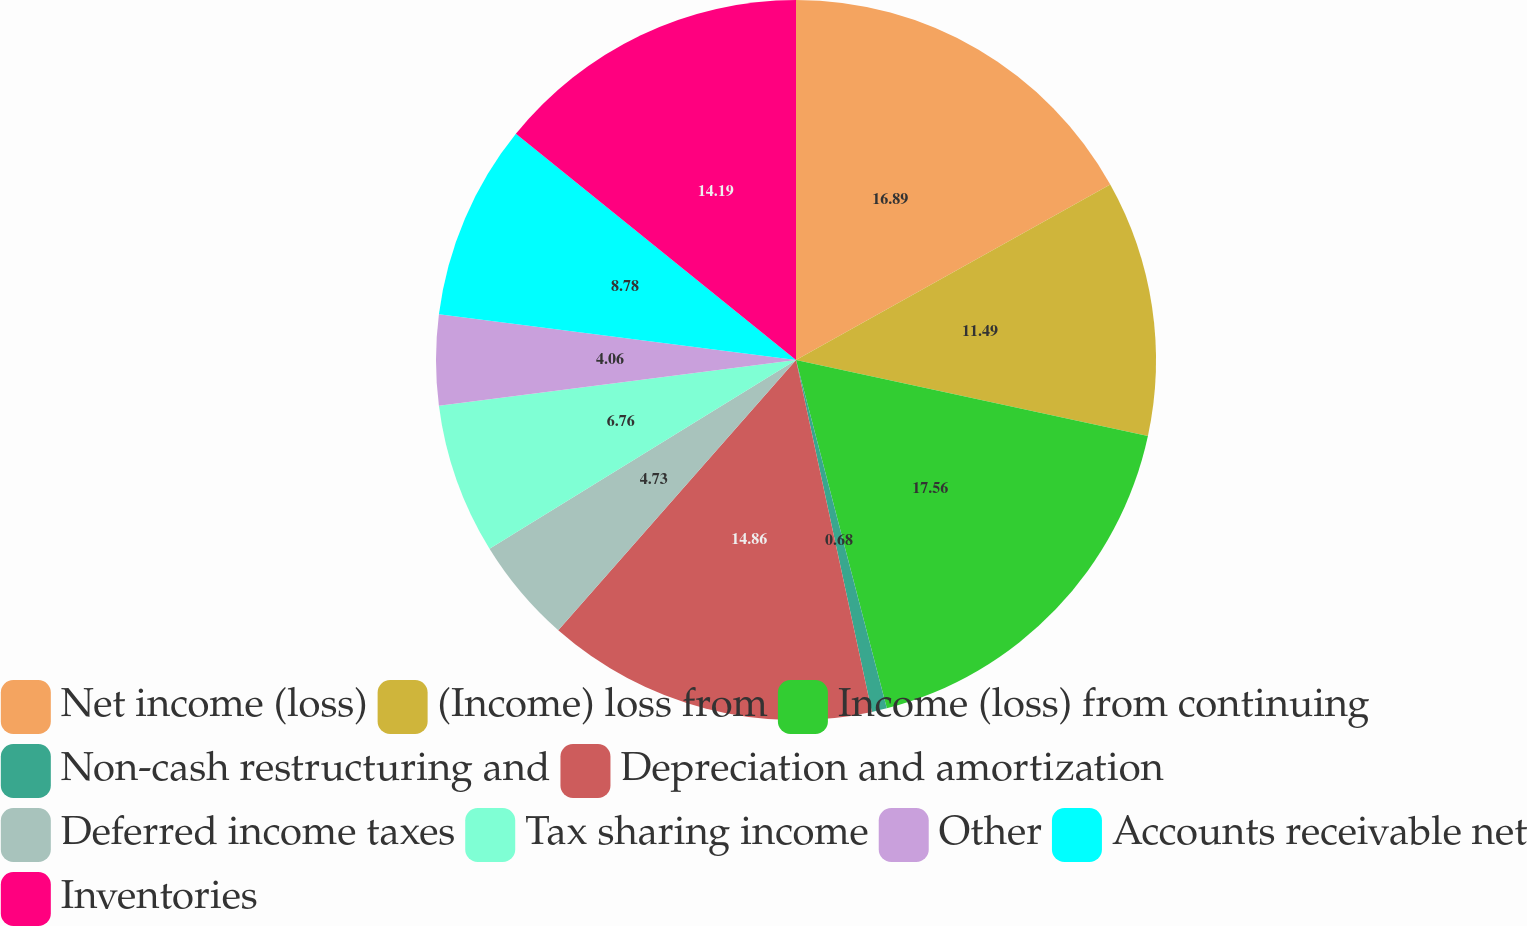Convert chart to OTSL. <chart><loc_0><loc_0><loc_500><loc_500><pie_chart><fcel>Net income (loss)<fcel>(Income) loss from<fcel>Income (loss) from continuing<fcel>Non-cash restructuring and<fcel>Depreciation and amortization<fcel>Deferred income taxes<fcel>Tax sharing income<fcel>Other<fcel>Accounts receivable net<fcel>Inventories<nl><fcel>16.89%<fcel>11.49%<fcel>17.56%<fcel>0.68%<fcel>14.86%<fcel>4.73%<fcel>6.76%<fcel>4.06%<fcel>8.78%<fcel>14.19%<nl></chart> 